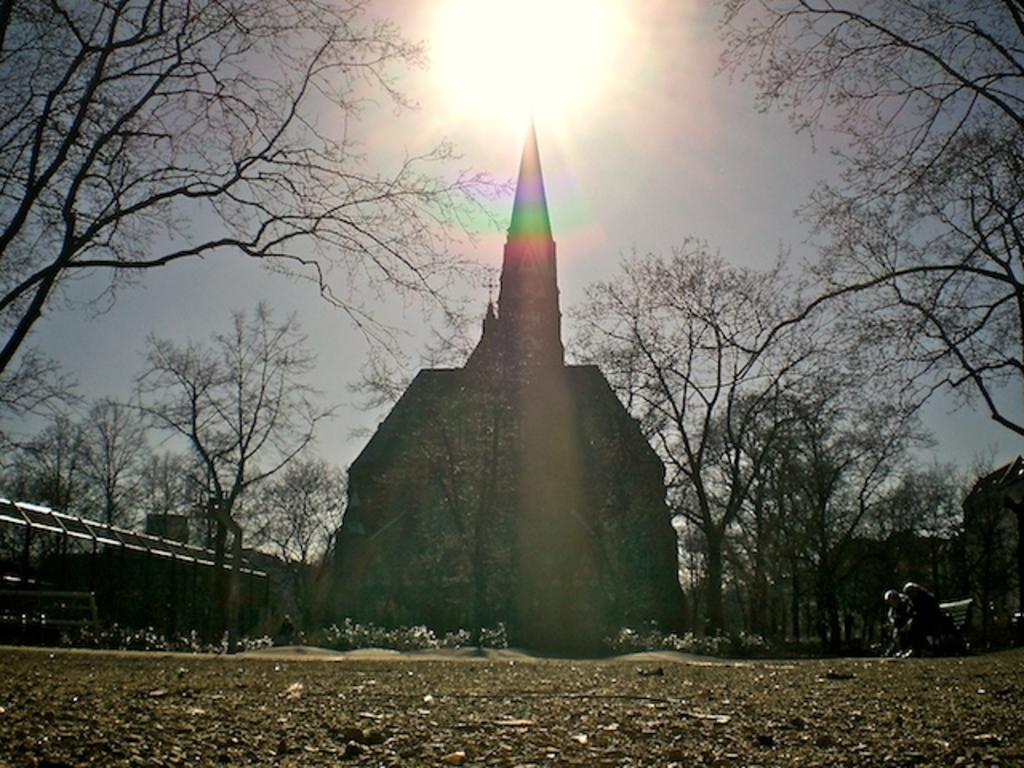What is the main feature of the image? There is an open area in the image. What are the two persons in the image doing? They are sitting on a bench in the image. What type of vegetation can be seen in the image? There are trees in the image. What is visible in the background of the image? There is a church in the background of the image. What is the weather like in the image? The sky is sunny in the image. How many sticks are being used by the persons sitting on the bench in the image? There are no sticks visible in the image; the persons are simply sitting on the bench. What type of shock can be seen affecting the trees in the image? There is no shock affecting the trees in the image; they appear to be normal and healthy. 